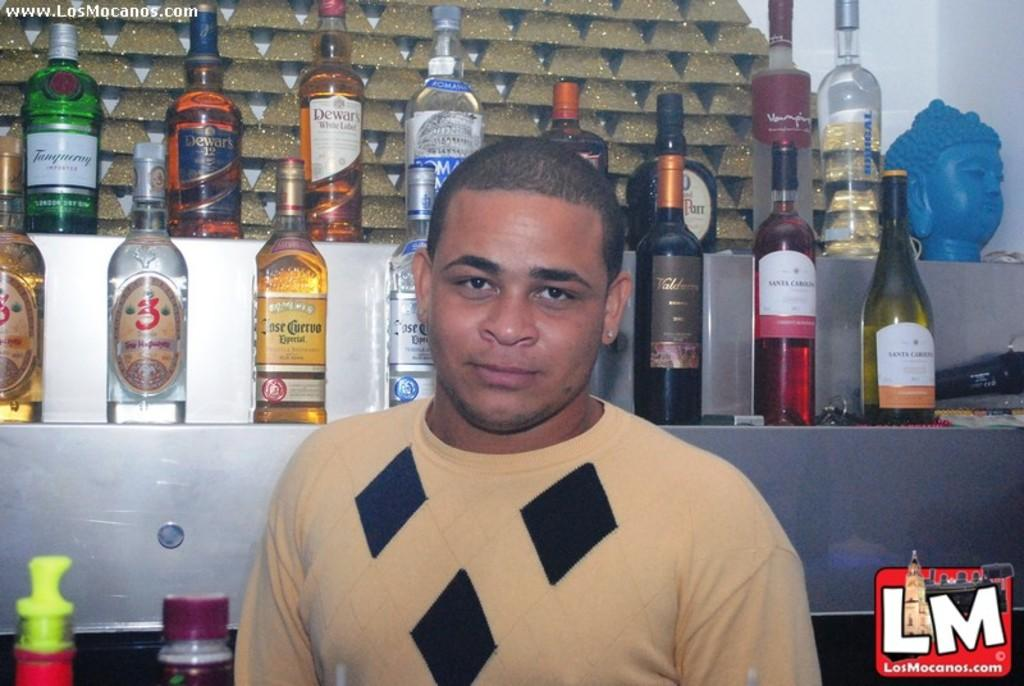What is the main subject of the image? There is a man in the image. What is the man wearing? The man is wearing a yellow t-shirt. What is the man's facial expression? The man is smiling. What can be seen in the background of the image? There are wine bottles on a shelf in the background of the image. What type of linen can be seen draped over the ship in the image? There is no ship or linen present in the image; it features a man wearing a yellow t-shirt and smiling. 